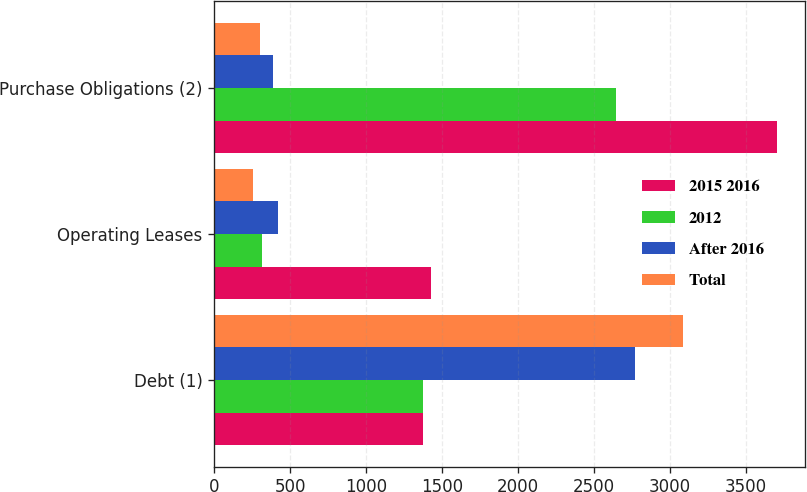Convert chart. <chart><loc_0><loc_0><loc_500><loc_500><stacked_bar_chart><ecel><fcel>Debt (1)<fcel>Operating Leases<fcel>Purchase Obligations (2)<nl><fcel>2015 2016<fcel>1377<fcel>1429<fcel>3707<nl><fcel>2012<fcel>1377<fcel>313<fcel>2647<nl><fcel>After 2016<fcel>2773<fcel>420<fcel>386<nl><fcel>Total<fcel>3089<fcel>255<fcel>298<nl></chart> 